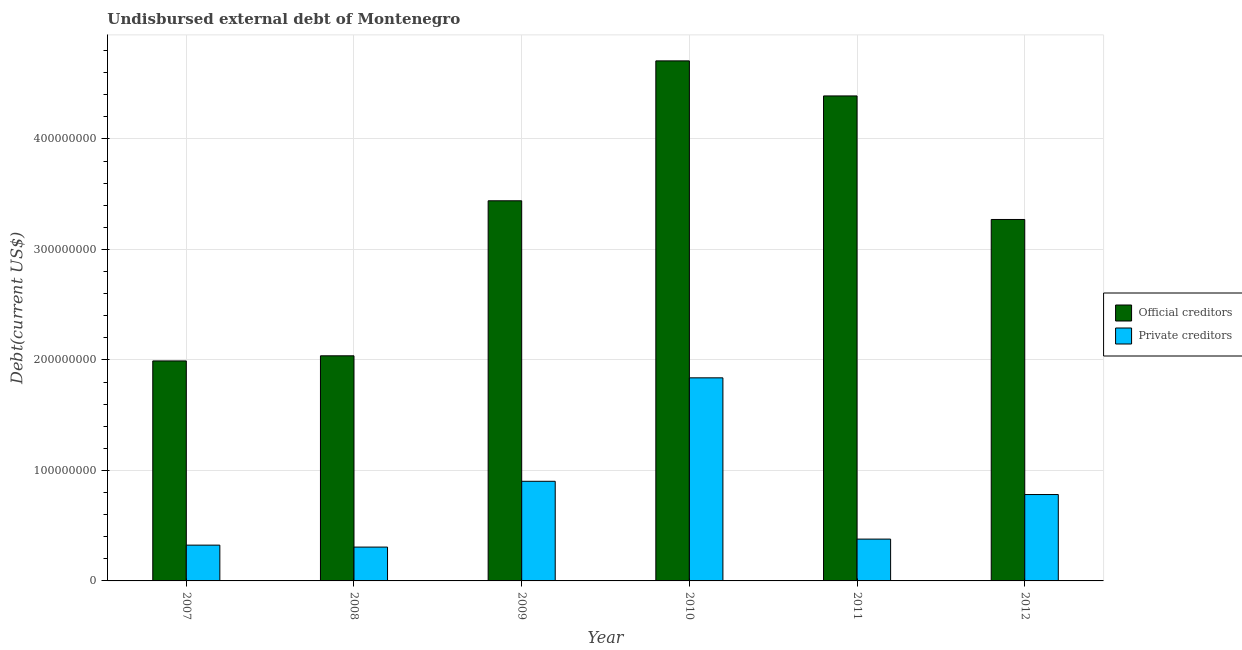How many different coloured bars are there?
Your answer should be very brief. 2. How many groups of bars are there?
Give a very brief answer. 6. Are the number of bars on each tick of the X-axis equal?
Your answer should be very brief. Yes. How many bars are there on the 3rd tick from the right?
Give a very brief answer. 2. What is the undisbursed external debt of private creditors in 2009?
Your answer should be very brief. 9.02e+07. Across all years, what is the maximum undisbursed external debt of private creditors?
Offer a very short reply. 1.84e+08. Across all years, what is the minimum undisbursed external debt of private creditors?
Offer a very short reply. 3.06e+07. In which year was the undisbursed external debt of official creditors maximum?
Keep it short and to the point. 2010. In which year was the undisbursed external debt of official creditors minimum?
Offer a terse response. 2007. What is the total undisbursed external debt of private creditors in the graph?
Provide a succinct answer. 4.53e+08. What is the difference between the undisbursed external debt of official creditors in 2008 and that in 2009?
Your response must be concise. -1.40e+08. What is the difference between the undisbursed external debt of official creditors in 2008 and the undisbursed external debt of private creditors in 2007?
Make the answer very short. 4.64e+06. What is the average undisbursed external debt of official creditors per year?
Offer a very short reply. 3.31e+08. What is the ratio of the undisbursed external debt of official creditors in 2010 to that in 2011?
Ensure brevity in your answer.  1.07. Is the undisbursed external debt of private creditors in 2007 less than that in 2012?
Make the answer very short. Yes. What is the difference between the highest and the second highest undisbursed external debt of private creditors?
Your answer should be compact. 9.36e+07. What is the difference between the highest and the lowest undisbursed external debt of official creditors?
Your answer should be compact. 2.72e+08. Is the sum of the undisbursed external debt of private creditors in 2008 and 2012 greater than the maximum undisbursed external debt of official creditors across all years?
Your response must be concise. No. What does the 1st bar from the left in 2009 represents?
Offer a very short reply. Official creditors. What does the 1st bar from the right in 2010 represents?
Make the answer very short. Private creditors. How many bars are there?
Offer a terse response. 12. What is the difference between two consecutive major ticks on the Y-axis?
Ensure brevity in your answer.  1.00e+08. Does the graph contain any zero values?
Provide a succinct answer. No. What is the title of the graph?
Make the answer very short. Undisbursed external debt of Montenegro. What is the label or title of the X-axis?
Your answer should be very brief. Year. What is the label or title of the Y-axis?
Provide a short and direct response. Debt(current US$). What is the Debt(current US$) in Official creditors in 2007?
Keep it short and to the point. 1.99e+08. What is the Debt(current US$) of Private creditors in 2007?
Ensure brevity in your answer.  3.24e+07. What is the Debt(current US$) of Official creditors in 2008?
Make the answer very short. 2.04e+08. What is the Debt(current US$) of Private creditors in 2008?
Offer a terse response. 3.06e+07. What is the Debt(current US$) of Official creditors in 2009?
Your response must be concise. 3.44e+08. What is the Debt(current US$) in Private creditors in 2009?
Offer a terse response. 9.02e+07. What is the Debt(current US$) of Official creditors in 2010?
Offer a very short reply. 4.71e+08. What is the Debt(current US$) in Private creditors in 2010?
Offer a terse response. 1.84e+08. What is the Debt(current US$) in Official creditors in 2011?
Your response must be concise. 4.39e+08. What is the Debt(current US$) in Private creditors in 2011?
Ensure brevity in your answer.  3.78e+07. What is the Debt(current US$) of Official creditors in 2012?
Give a very brief answer. 3.27e+08. What is the Debt(current US$) in Private creditors in 2012?
Provide a succinct answer. 7.82e+07. Across all years, what is the maximum Debt(current US$) in Official creditors?
Provide a short and direct response. 4.71e+08. Across all years, what is the maximum Debt(current US$) in Private creditors?
Provide a succinct answer. 1.84e+08. Across all years, what is the minimum Debt(current US$) in Official creditors?
Your response must be concise. 1.99e+08. Across all years, what is the minimum Debt(current US$) in Private creditors?
Your answer should be very brief. 3.06e+07. What is the total Debt(current US$) of Official creditors in the graph?
Your answer should be very brief. 1.98e+09. What is the total Debt(current US$) of Private creditors in the graph?
Provide a short and direct response. 4.53e+08. What is the difference between the Debt(current US$) in Official creditors in 2007 and that in 2008?
Offer a very short reply. -4.64e+06. What is the difference between the Debt(current US$) of Private creditors in 2007 and that in 2008?
Ensure brevity in your answer.  1.77e+06. What is the difference between the Debt(current US$) of Official creditors in 2007 and that in 2009?
Ensure brevity in your answer.  -1.45e+08. What is the difference between the Debt(current US$) of Private creditors in 2007 and that in 2009?
Your response must be concise. -5.78e+07. What is the difference between the Debt(current US$) of Official creditors in 2007 and that in 2010?
Keep it short and to the point. -2.72e+08. What is the difference between the Debt(current US$) of Private creditors in 2007 and that in 2010?
Give a very brief answer. -1.51e+08. What is the difference between the Debt(current US$) of Official creditors in 2007 and that in 2011?
Keep it short and to the point. -2.40e+08. What is the difference between the Debt(current US$) of Private creditors in 2007 and that in 2011?
Provide a short and direct response. -5.46e+06. What is the difference between the Debt(current US$) in Official creditors in 2007 and that in 2012?
Ensure brevity in your answer.  -1.28e+08. What is the difference between the Debt(current US$) of Private creditors in 2007 and that in 2012?
Give a very brief answer. -4.58e+07. What is the difference between the Debt(current US$) in Official creditors in 2008 and that in 2009?
Your answer should be compact. -1.40e+08. What is the difference between the Debt(current US$) of Private creditors in 2008 and that in 2009?
Keep it short and to the point. -5.96e+07. What is the difference between the Debt(current US$) in Official creditors in 2008 and that in 2010?
Provide a short and direct response. -2.67e+08. What is the difference between the Debt(current US$) in Private creditors in 2008 and that in 2010?
Provide a short and direct response. -1.53e+08. What is the difference between the Debt(current US$) of Official creditors in 2008 and that in 2011?
Keep it short and to the point. -2.35e+08. What is the difference between the Debt(current US$) of Private creditors in 2008 and that in 2011?
Offer a very short reply. -7.23e+06. What is the difference between the Debt(current US$) in Official creditors in 2008 and that in 2012?
Ensure brevity in your answer.  -1.23e+08. What is the difference between the Debt(current US$) of Private creditors in 2008 and that in 2012?
Make the answer very short. -4.76e+07. What is the difference between the Debt(current US$) in Official creditors in 2009 and that in 2010?
Keep it short and to the point. -1.27e+08. What is the difference between the Debt(current US$) in Private creditors in 2009 and that in 2010?
Your answer should be very brief. -9.36e+07. What is the difference between the Debt(current US$) in Official creditors in 2009 and that in 2011?
Ensure brevity in your answer.  -9.49e+07. What is the difference between the Debt(current US$) in Private creditors in 2009 and that in 2011?
Your response must be concise. 5.23e+07. What is the difference between the Debt(current US$) in Official creditors in 2009 and that in 2012?
Provide a short and direct response. 1.69e+07. What is the difference between the Debt(current US$) in Private creditors in 2009 and that in 2012?
Provide a short and direct response. 1.20e+07. What is the difference between the Debt(current US$) of Official creditors in 2010 and that in 2011?
Give a very brief answer. 3.17e+07. What is the difference between the Debt(current US$) of Private creditors in 2010 and that in 2011?
Make the answer very short. 1.46e+08. What is the difference between the Debt(current US$) in Official creditors in 2010 and that in 2012?
Offer a terse response. 1.44e+08. What is the difference between the Debt(current US$) in Private creditors in 2010 and that in 2012?
Offer a very short reply. 1.06e+08. What is the difference between the Debt(current US$) in Official creditors in 2011 and that in 2012?
Provide a succinct answer. 1.12e+08. What is the difference between the Debt(current US$) of Private creditors in 2011 and that in 2012?
Your answer should be very brief. -4.03e+07. What is the difference between the Debt(current US$) of Official creditors in 2007 and the Debt(current US$) of Private creditors in 2008?
Offer a very short reply. 1.68e+08. What is the difference between the Debt(current US$) of Official creditors in 2007 and the Debt(current US$) of Private creditors in 2009?
Provide a short and direct response. 1.09e+08. What is the difference between the Debt(current US$) of Official creditors in 2007 and the Debt(current US$) of Private creditors in 2010?
Make the answer very short. 1.53e+07. What is the difference between the Debt(current US$) in Official creditors in 2007 and the Debt(current US$) in Private creditors in 2011?
Provide a succinct answer. 1.61e+08. What is the difference between the Debt(current US$) of Official creditors in 2007 and the Debt(current US$) of Private creditors in 2012?
Your answer should be very brief. 1.21e+08. What is the difference between the Debt(current US$) in Official creditors in 2008 and the Debt(current US$) in Private creditors in 2009?
Offer a terse response. 1.14e+08. What is the difference between the Debt(current US$) in Official creditors in 2008 and the Debt(current US$) in Private creditors in 2010?
Offer a terse response. 1.99e+07. What is the difference between the Debt(current US$) in Official creditors in 2008 and the Debt(current US$) in Private creditors in 2011?
Ensure brevity in your answer.  1.66e+08. What is the difference between the Debt(current US$) in Official creditors in 2008 and the Debt(current US$) in Private creditors in 2012?
Make the answer very short. 1.26e+08. What is the difference between the Debt(current US$) in Official creditors in 2009 and the Debt(current US$) in Private creditors in 2010?
Your answer should be compact. 1.60e+08. What is the difference between the Debt(current US$) in Official creditors in 2009 and the Debt(current US$) in Private creditors in 2011?
Provide a short and direct response. 3.06e+08. What is the difference between the Debt(current US$) in Official creditors in 2009 and the Debt(current US$) in Private creditors in 2012?
Ensure brevity in your answer.  2.66e+08. What is the difference between the Debt(current US$) in Official creditors in 2010 and the Debt(current US$) in Private creditors in 2011?
Ensure brevity in your answer.  4.33e+08. What is the difference between the Debt(current US$) of Official creditors in 2010 and the Debt(current US$) of Private creditors in 2012?
Your answer should be very brief. 3.92e+08. What is the difference between the Debt(current US$) in Official creditors in 2011 and the Debt(current US$) in Private creditors in 2012?
Offer a terse response. 3.61e+08. What is the average Debt(current US$) of Official creditors per year?
Give a very brief answer. 3.31e+08. What is the average Debt(current US$) of Private creditors per year?
Your answer should be very brief. 7.55e+07. In the year 2007, what is the difference between the Debt(current US$) of Official creditors and Debt(current US$) of Private creditors?
Make the answer very short. 1.67e+08. In the year 2008, what is the difference between the Debt(current US$) of Official creditors and Debt(current US$) of Private creditors?
Your response must be concise. 1.73e+08. In the year 2009, what is the difference between the Debt(current US$) of Official creditors and Debt(current US$) of Private creditors?
Your answer should be compact. 2.54e+08. In the year 2010, what is the difference between the Debt(current US$) in Official creditors and Debt(current US$) in Private creditors?
Offer a very short reply. 2.87e+08. In the year 2011, what is the difference between the Debt(current US$) of Official creditors and Debt(current US$) of Private creditors?
Provide a short and direct response. 4.01e+08. In the year 2012, what is the difference between the Debt(current US$) in Official creditors and Debt(current US$) in Private creditors?
Your response must be concise. 2.49e+08. What is the ratio of the Debt(current US$) of Official creditors in 2007 to that in 2008?
Give a very brief answer. 0.98. What is the ratio of the Debt(current US$) in Private creditors in 2007 to that in 2008?
Provide a succinct answer. 1.06. What is the ratio of the Debt(current US$) of Official creditors in 2007 to that in 2009?
Offer a terse response. 0.58. What is the ratio of the Debt(current US$) of Private creditors in 2007 to that in 2009?
Provide a short and direct response. 0.36. What is the ratio of the Debt(current US$) of Official creditors in 2007 to that in 2010?
Offer a very short reply. 0.42. What is the ratio of the Debt(current US$) in Private creditors in 2007 to that in 2010?
Your answer should be compact. 0.18. What is the ratio of the Debt(current US$) of Official creditors in 2007 to that in 2011?
Your answer should be compact. 0.45. What is the ratio of the Debt(current US$) in Private creditors in 2007 to that in 2011?
Your answer should be compact. 0.86. What is the ratio of the Debt(current US$) of Official creditors in 2007 to that in 2012?
Your answer should be compact. 0.61. What is the ratio of the Debt(current US$) in Private creditors in 2007 to that in 2012?
Your response must be concise. 0.41. What is the ratio of the Debt(current US$) of Official creditors in 2008 to that in 2009?
Give a very brief answer. 0.59. What is the ratio of the Debt(current US$) in Private creditors in 2008 to that in 2009?
Ensure brevity in your answer.  0.34. What is the ratio of the Debt(current US$) of Official creditors in 2008 to that in 2010?
Provide a succinct answer. 0.43. What is the ratio of the Debt(current US$) in Private creditors in 2008 to that in 2010?
Make the answer very short. 0.17. What is the ratio of the Debt(current US$) in Official creditors in 2008 to that in 2011?
Ensure brevity in your answer.  0.46. What is the ratio of the Debt(current US$) in Private creditors in 2008 to that in 2011?
Your answer should be compact. 0.81. What is the ratio of the Debt(current US$) of Official creditors in 2008 to that in 2012?
Provide a short and direct response. 0.62. What is the ratio of the Debt(current US$) of Private creditors in 2008 to that in 2012?
Offer a terse response. 0.39. What is the ratio of the Debt(current US$) of Official creditors in 2009 to that in 2010?
Provide a succinct answer. 0.73. What is the ratio of the Debt(current US$) in Private creditors in 2009 to that in 2010?
Provide a succinct answer. 0.49. What is the ratio of the Debt(current US$) of Official creditors in 2009 to that in 2011?
Offer a terse response. 0.78. What is the ratio of the Debt(current US$) in Private creditors in 2009 to that in 2011?
Offer a terse response. 2.38. What is the ratio of the Debt(current US$) of Official creditors in 2009 to that in 2012?
Your answer should be very brief. 1.05. What is the ratio of the Debt(current US$) of Private creditors in 2009 to that in 2012?
Keep it short and to the point. 1.15. What is the ratio of the Debt(current US$) of Official creditors in 2010 to that in 2011?
Make the answer very short. 1.07. What is the ratio of the Debt(current US$) of Private creditors in 2010 to that in 2011?
Provide a short and direct response. 4.86. What is the ratio of the Debt(current US$) in Official creditors in 2010 to that in 2012?
Your response must be concise. 1.44. What is the ratio of the Debt(current US$) of Private creditors in 2010 to that in 2012?
Your answer should be very brief. 2.35. What is the ratio of the Debt(current US$) of Official creditors in 2011 to that in 2012?
Offer a terse response. 1.34. What is the ratio of the Debt(current US$) of Private creditors in 2011 to that in 2012?
Your answer should be very brief. 0.48. What is the difference between the highest and the second highest Debt(current US$) in Official creditors?
Your answer should be compact. 3.17e+07. What is the difference between the highest and the second highest Debt(current US$) in Private creditors?
Offer a very short reply. 9.36e+07. What is the difference between the highest and the lowest Debt(current US$) of Official creditors?
Your response must be concise. 2.72e+08. What is the difference between the highest and the lowest Debt(current US$) of Private creditors?
Your response must be concise. 1.53e+08. 